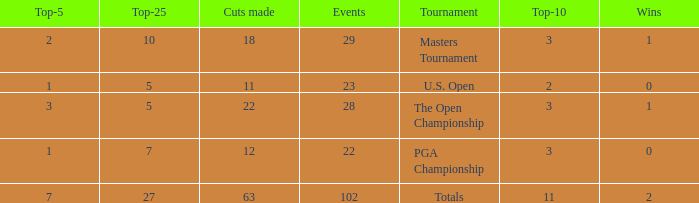How many vuts made for a player with 2 wins and under 7 top 5s? None. 